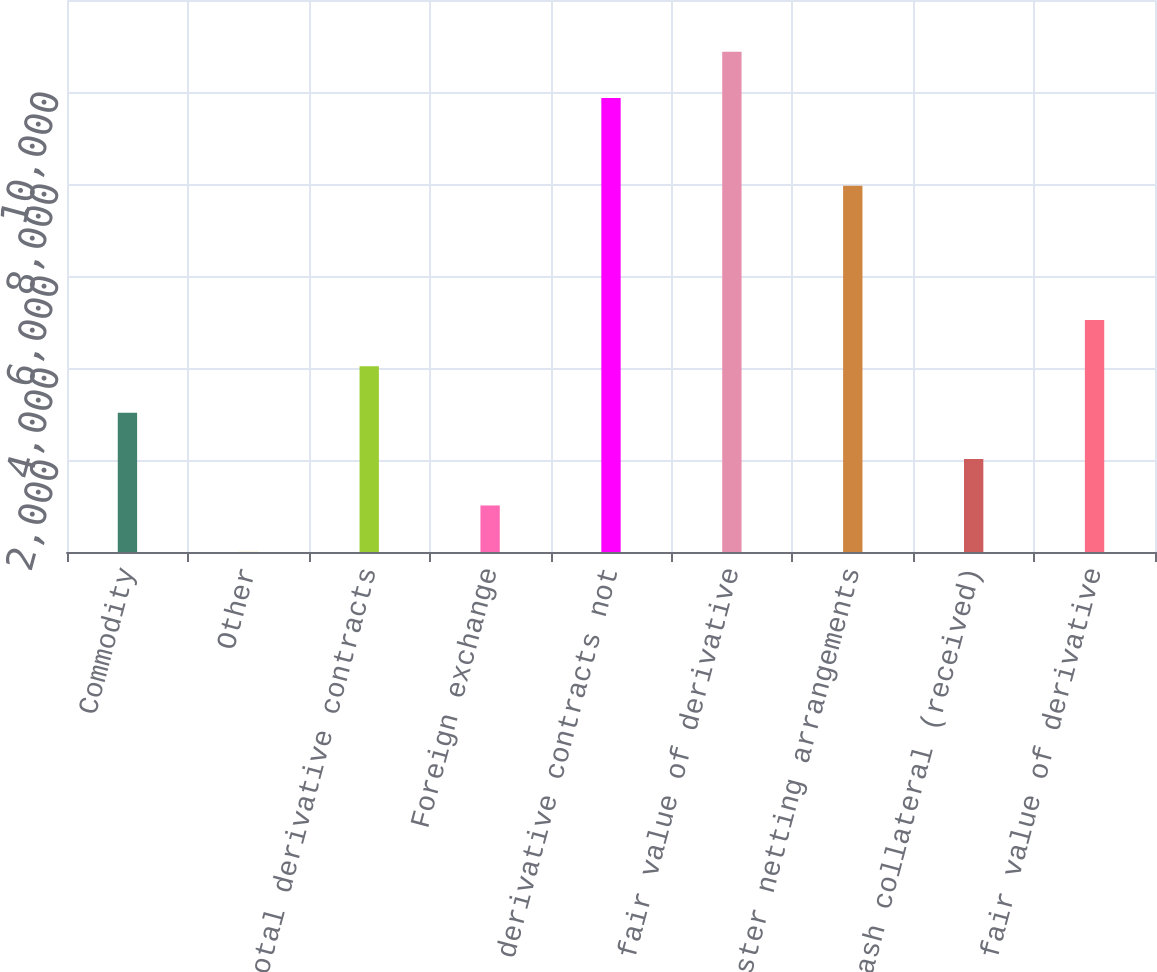Convert chart. <chart><loc_0><loc_0><loc_500><loc_500><bar_chart><fcel>Commodity<fcel>Other<fcel>Total derivative contracts<fcel>Foreign exchange<fcel>Total derivative contracts not<fcel>Gross fair value of derivative<fcel>Master netting arrangements<fcel>Cash collateral (received)<fcel>Net fair value of derivative<nl><fcel>3028.2<fcel>3<fcel>4036.6<fcel>1011.4<fcel>9868<fcel>10876.4<fcel>7962<fcel>2019.8<fcel>5045<nl></chart> 